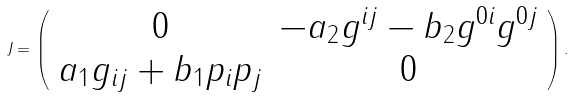<formula> <loc_0><loc_0><loc_500><loc_500>J = \left ( \begin{array} { c c } 0 & - a _ { 2 } g ^ { i j } - b _ { 2 } g ^ { 0 i } g ^ { 0 j } \\ a _ { 1 } g _ { i j } + b _ { 1 } p _ { i } p _ { j } & 0 \end{array} \right ) .</formula> 